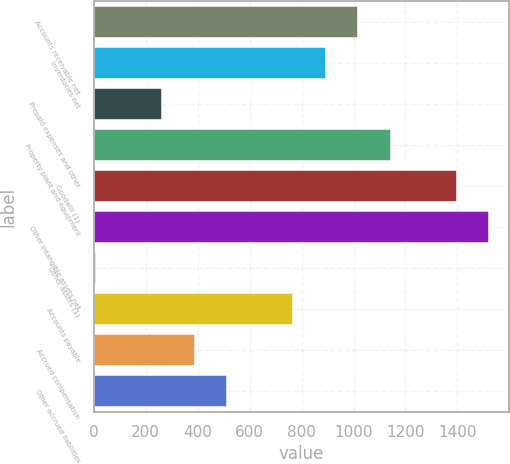Convert chart to OTSL. <chart><loc_0><loc_0><loc_500><loc_500><bar_chart><fcel>Accounts receivable net<fcel>Inventories net<fcel>Prepaid expenses and other<fcel>Property plant and equipment<fcel>Goodwill (1)<fcel>Other intangible assets net<fcel>Other assets (1)<fcel>Accounts payable<fcel>Accrued compensation<fcel>Other accrued liabilities<nl><fcel>1018.52<fcel>892.38<fcel>261.68<fcel>1144.66<fcel>1396.94<fcel>1523.08<fcel>9.4<fcel>766.24<fcel>387.82<fcel>513.96<nl></chart> 